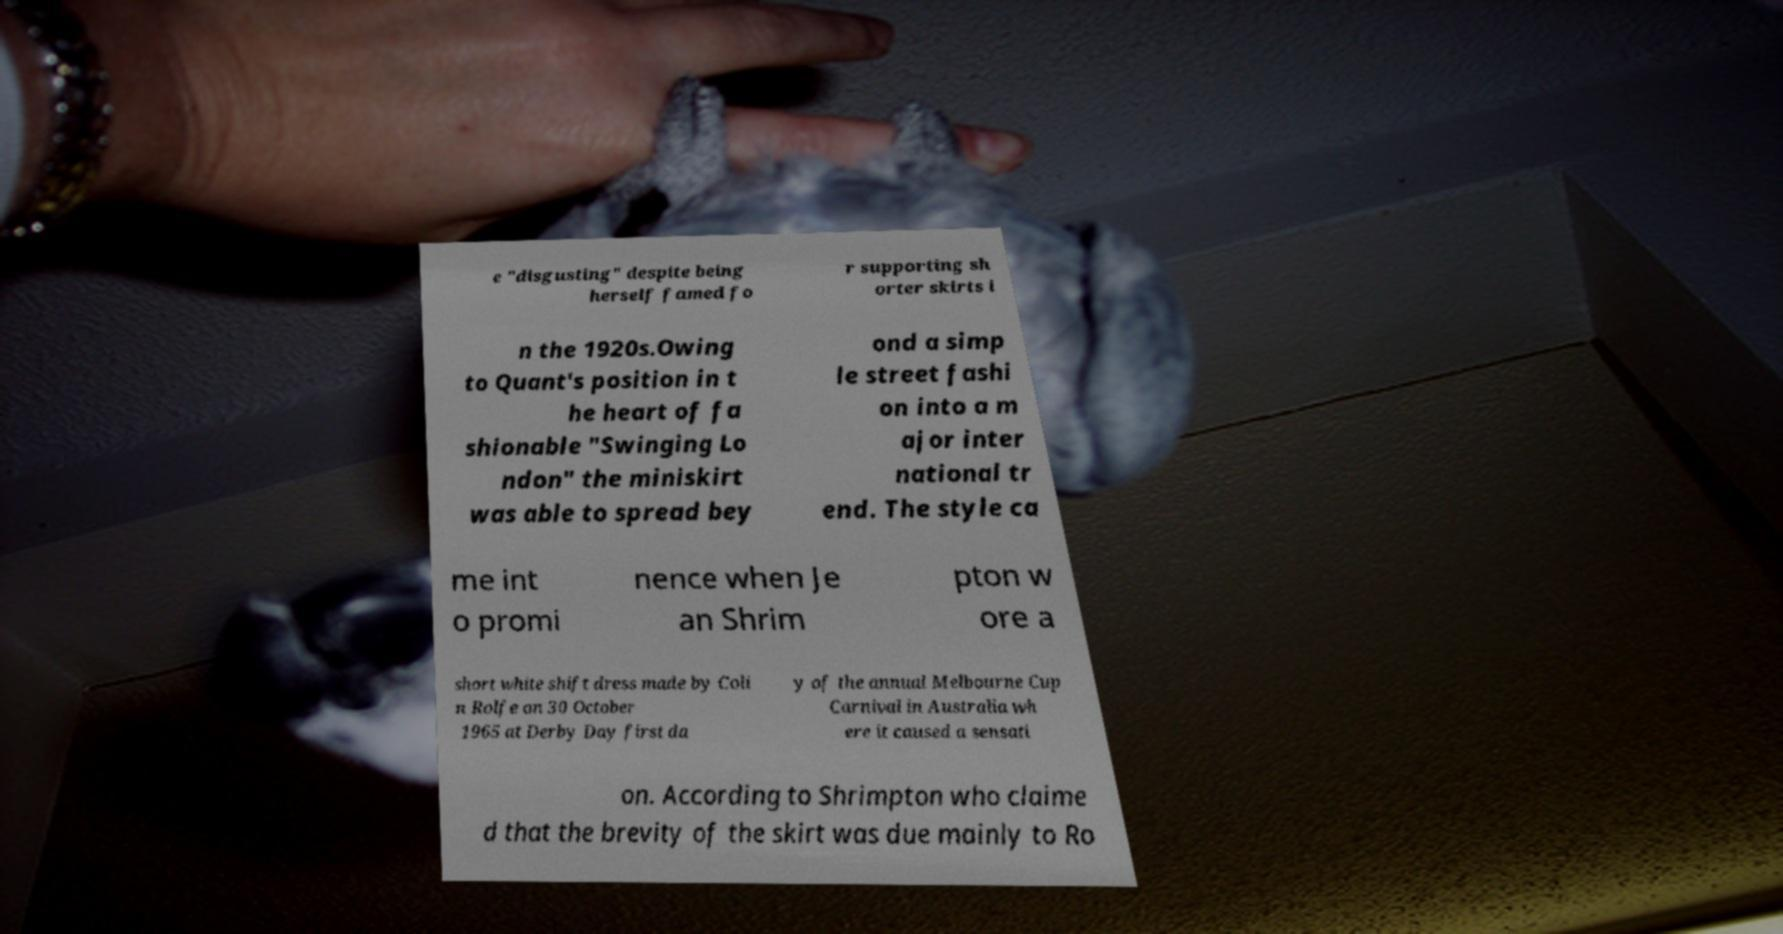I need the written content from this picture converted into text. Can you do that? e "disgusting" despite being herself famed fo r supporting sh orter skirts i n the 1920s.Owing to Quant's position in t he heart of fa shionable "Swinging Lo ndon" the miniskirt was able to spread bey ond a simp le street fashi on into a m ajor inter national tr end. The style ca me int o promi nence when Je an Shrim pton w ore a short white shift dress made by Coli n Rolfe on 30 October 1965 at Derby Day first da y of the annual Melbourne Cup Carnival in Australia wh ere it caused a sensati on. According to Shrimpton who claime d that the brevity of the skirt was due mainly to Ro 